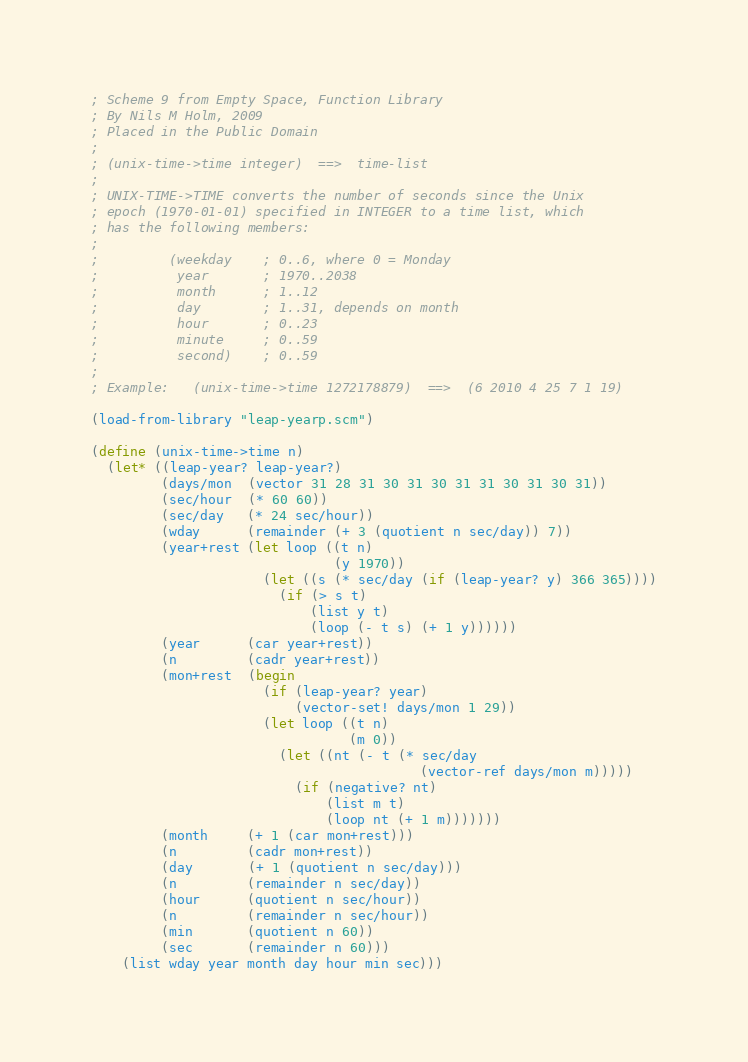<code> <loc_0><loc_0><loc_500><loc_500><_Scheme_>; Scheme 9 from Empty Space, Function Library
; By Nils M Holm, 2009
; Placed in the Public Domain
;
; (unix-time->time integer)  ==>  time-list
;
; UNIX-TIME->TIME converts the number of seconds since the Unix
; epoch (1970-01-01) specified in INTEGER to a time list, which
; has the following members:
;
;         (weekday    ; 0..6, where 0 = Monday
;          year       ; 1970..2038
;          month      ; 1..12
;          day        ; 1..31, depends on month
;          hour       ; 0..23
;          minute     ; 0..59
;          second)    ; 0..59
;
; Example:   (unix-time->time 1272178879)  ==>  (6 2010 4 25 7 1 19)

(load-from-library "leap-yearp.scm")

(define (unix-time->time n)
  (let* ((leap-year? leap-year?)
         (days/mon  (vector 31 28 31 30 31 30 31 31 30 31 30 31))
         (sec/hour  (* 60 60))
         (sec/day   (* 24 sec/hour))
         (wday      (remainder (+ 3 (quotient n sec/day)) 7))
         (year+rest (let loop ((t n)
                               (y 1970))
                      (let ((s (* sec/day (if (leap-year? y) 366 365))))
                        (if (> s t)
                            (list y t)
                            (loop (- t s) (+ 1 y))))))
         (year      (car year+rest))
         (n         (cadr year+rest))
         (mon+rest  (begin
                      (if (leap-year? year)
                          (vector-set! days/mon 1 29))
                      (let loop ((t n)
                                 (m 0))
                        (let ((nt (- t (* sec/day
                                          (vector-ref days/mon m)))))
                          (if (negative? nt)
                              (list m t)
                              (loop nt (+ 1 m)))))))
         (month     (+ 1 (car mon+rest)))
         (n         (cadr mon+rest))
         (day       (+ 1 (quotient n sec/day)))
         (n         (remainder n sec/day))
         (hour      (quotient n sec/hour))
         (n         (remainder n sec/hour))
         (min       (quotient n 60))
         (sec       (remainder n 60)))
    (list wday year month day hour min sec)))
</code> 